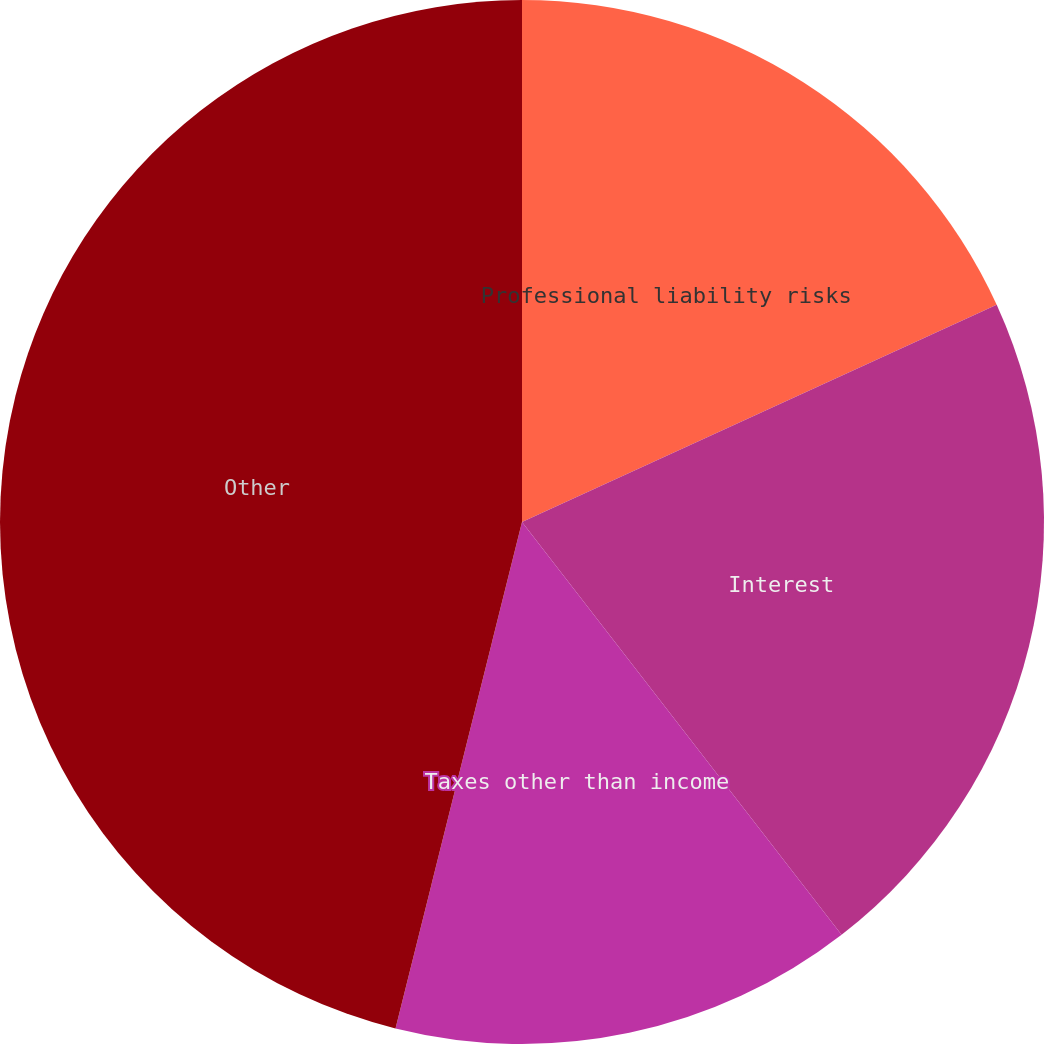Convert chart to OTSL. <chart><loc_0><loc_0><loc_500><loc_500><pie_chart><fcel>Professional liability risks<fcel>Interest<fcel>Taxes other than income<fcel>Other<nl><fcel>18.17%<fcel>21.34%<fcel>14.38%<fcel>46.1%<nl></chart> 